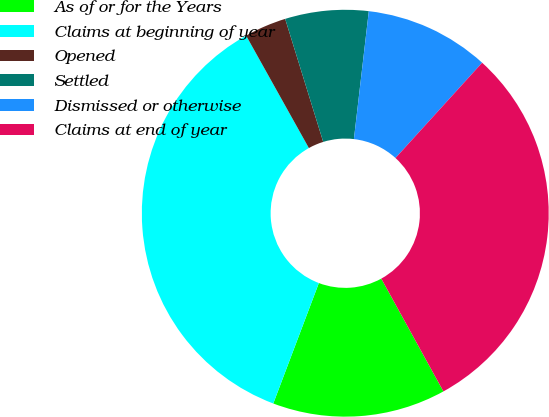Convert chart. <chart><loc_0><loc_0><loc_500><loc_500><pie_chart><fcel>As of or for the Years<fcel>Claims at beginning of year<fcel>Opened<fcel>Settled<fcel>Dismissed or otherwise<fcel>Claims at end of year<nl><fcel>13.77%<fcel>36.14%<fcel>3.33%<fcel>6.62%<fcel>9.9%<fcel>30.24%<nl></chart> 